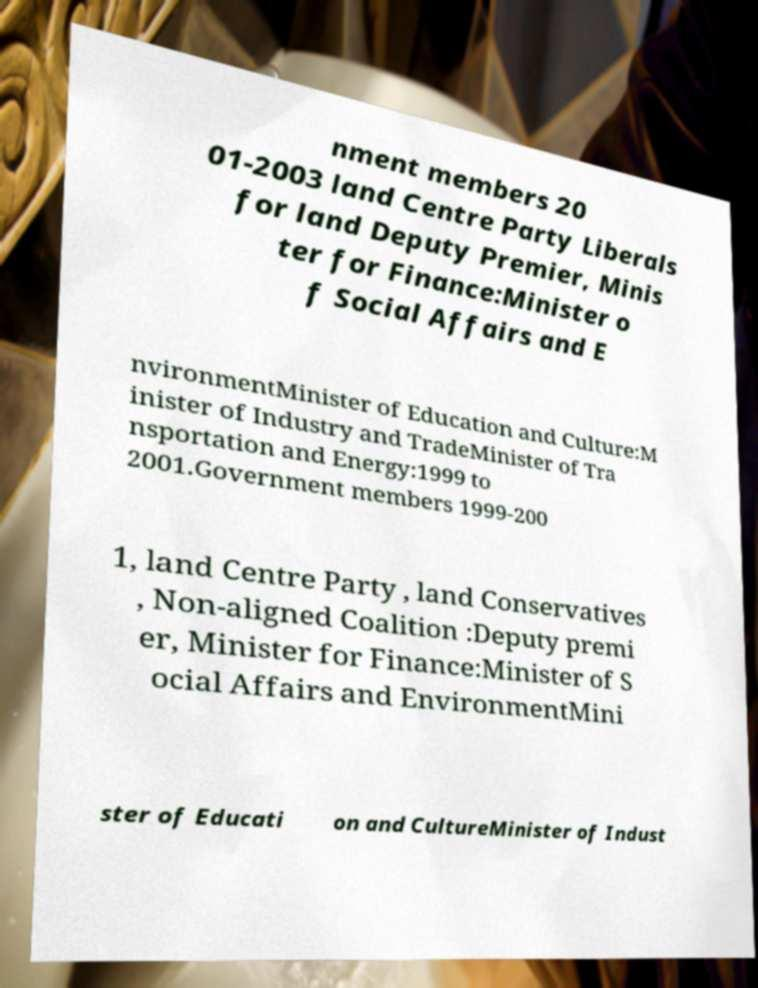I need the written content from this picture converted into text. Can you do that? nment members 20 01-2003 land Centre Party Liberals for land Deputy Premier, Minis ter for Finance:Minister o f Social Affairs and E nvironmentMinister of Education and Culture:M inister of Industry and TradeMinister of Tra nsportation and Energy:1999 to 2001.Government members 1999-200 1, land Centre Party , land Conservatives , Non-aligned Coalition :Deputy premi er, Minister for Finance:Minister of S ocial Affairs and EnvironmentMini ster of Educati on and CultureMinister of Indust 